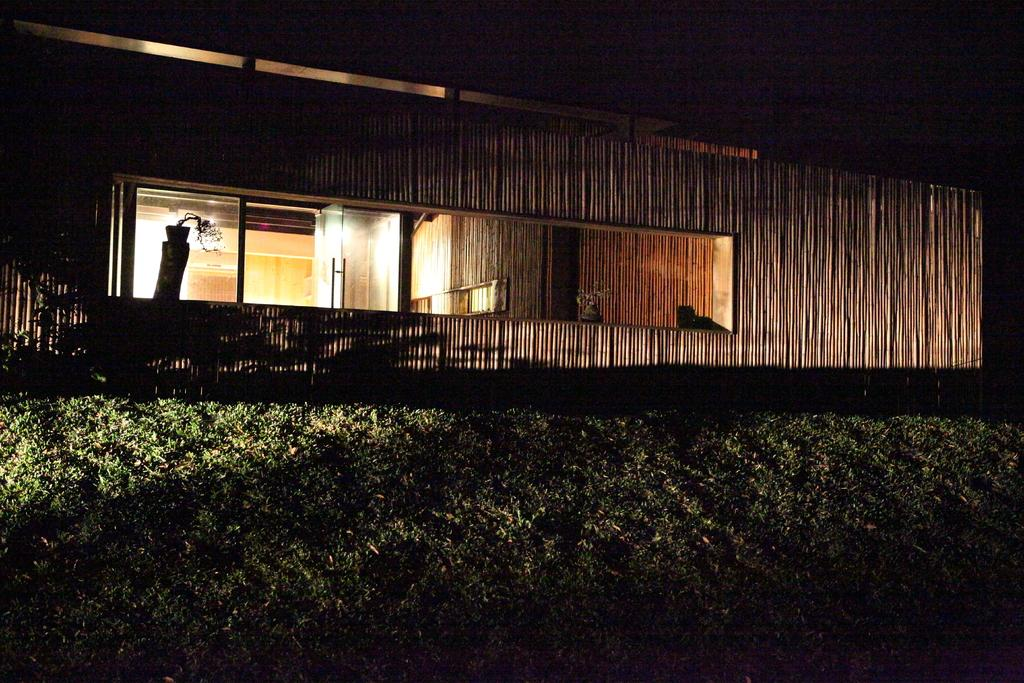What type of living organisms can be seen in the image? Plants can be seen in the image. What type of structure is visible in the image? There is a house in the image. What type of door can be seen in the image? There is a glass door in the image. Where is the sister sitting on her throne in the image? There is no sister or throne present in the image. 